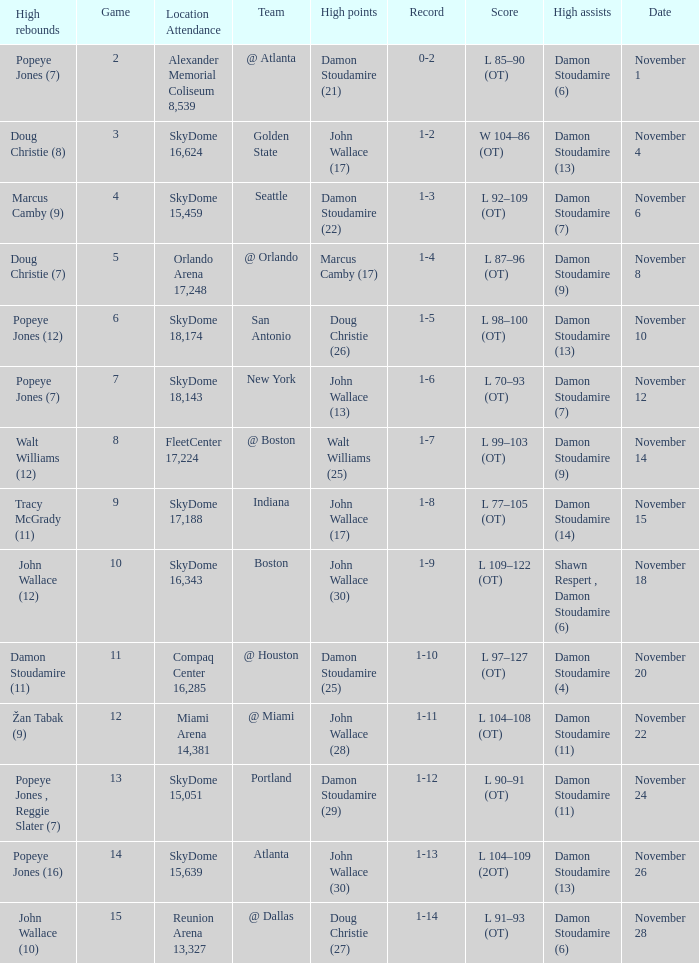What was the score against san antonio? L 98–100 (OT). 